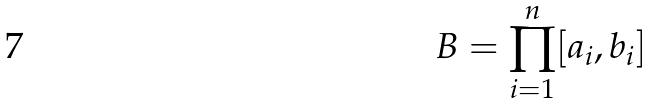Convert formula to latex. <formula><loc_0><loc_0><loc_500><loc_500>B = \prod _ { i = 1 } ^ { n } [ a _ { i } , b _ { i } ]</formula> 